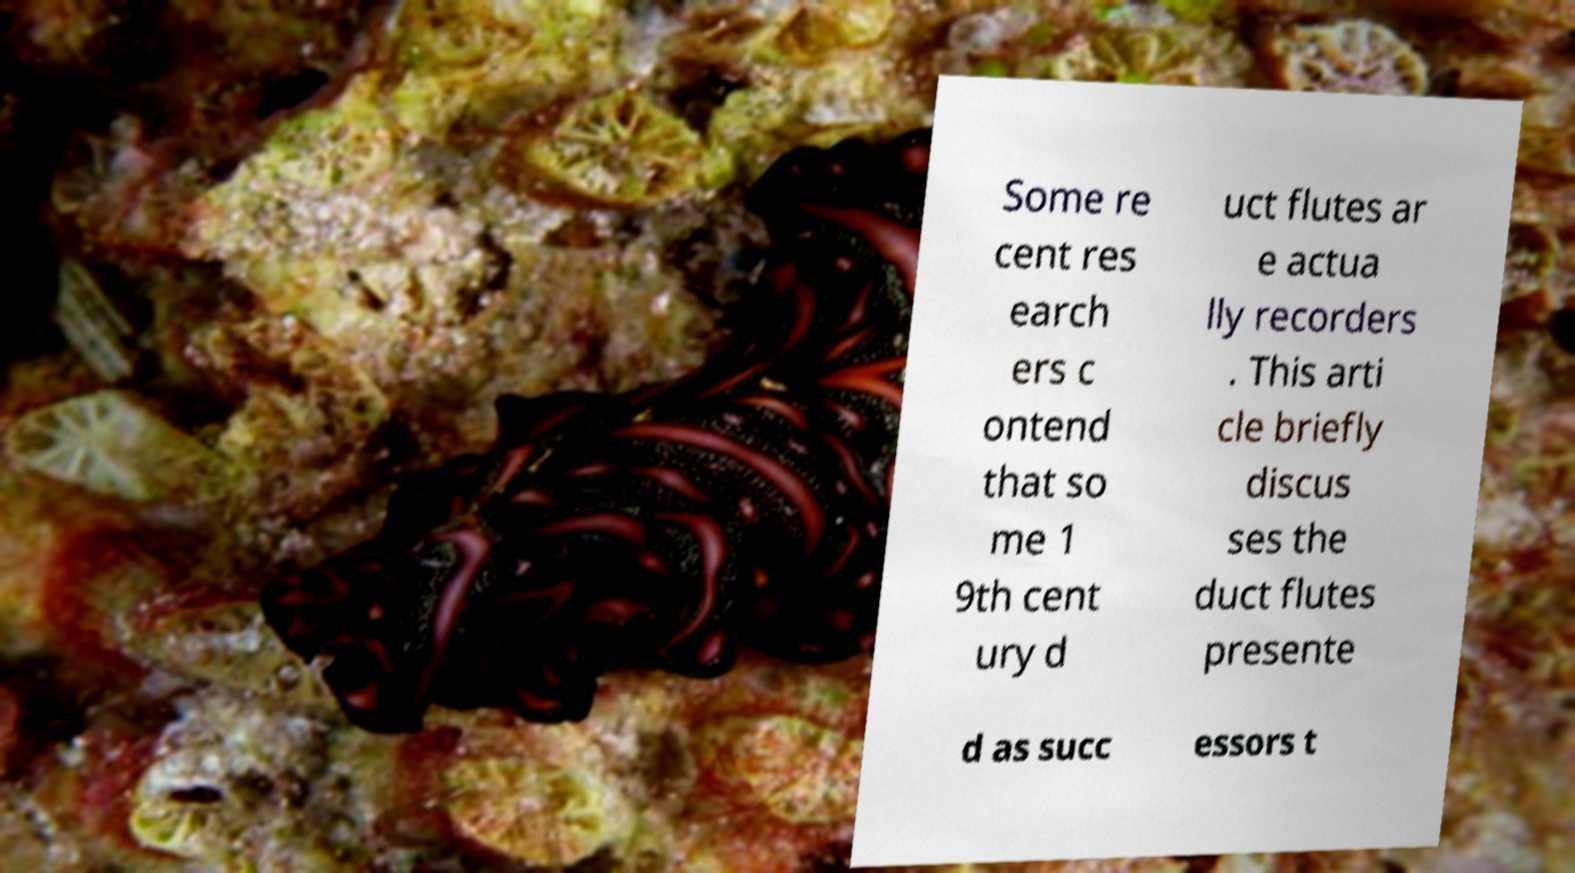Can you read and provide the text displayed in the image?This photo seems to have some interesting text. Can you extract and type it out for me? Some re cent res earch ers c ontend that so me 1 9th cent ury d uct flutes ar e actua lly recorders . This arti cle briefly discus ses the duct flutes presente d as succ essors t 